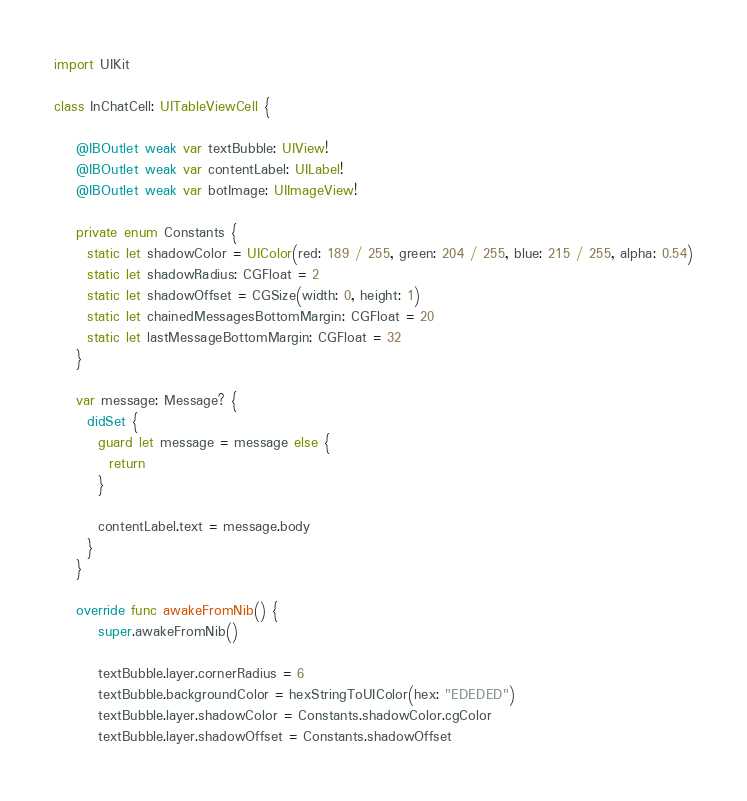Convert code to text. <code><loc_0><loc_0><loc_500><loc_500><_Swift_>import UIKit

class InChatCell: UITableViewCell {

    @IBOutlet weak var textBubble: UIView!
    @IBOutlet weak var contentLabel: UILabel!
    @IBOutlet weak var botImage: UIImageView!
    
    private enum Constants {
      static let shadowColor = UIColor(red: 189 / 255, green: 204 / 255, blue: 215 / 255, alpha: 0.54)
      static let shadowRadius: CGFloat = 2
      static let shadowOffset = CGSize(width: 0, height: 1)
      static let chainedMessagesBottomMargin: CGFloat = 20
      static let lastMessageBottomMargin: CGFloat = 32
    }
    
    var message: Message? {
      didSet {
        guard let message = message else {
          return
        }
        
        contentLabel.text = message.body
      }
    }
    
    override func awakeFromNib() {
        super.awakeFromNib()
        
        textBubble.layer.cornerRadius = 6
        textBubble.backgroundColor = hexStringToUIColor(hex: "EDEDED")
        textBubble.layer.shadowColor = Constants.shadowColor.cgColor
        textBubble.layer.shadowOffset = Constants.shadowOffset</code> 